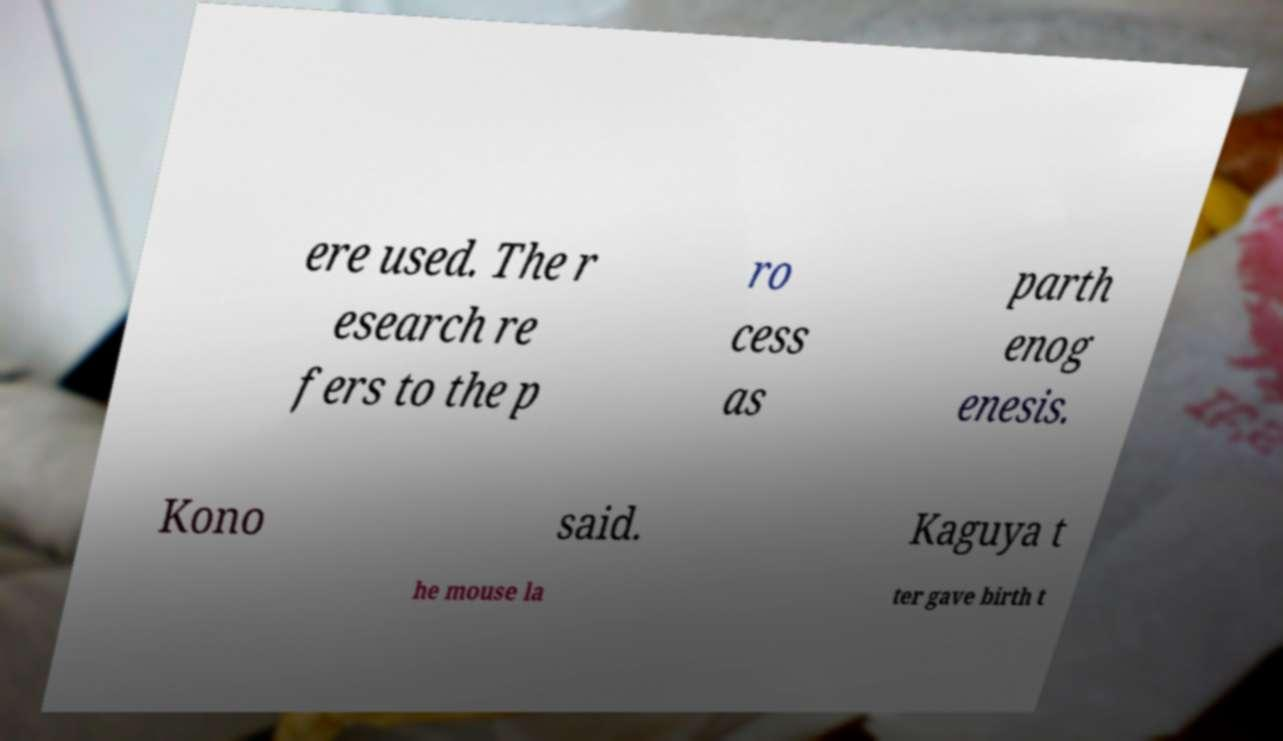Please identify and transcribe the text found in this image. ere used. The r esearch re fers to the p ro cess as parth enog enesis. Kono said. Kaguya t he mouse la ter gave birth t 